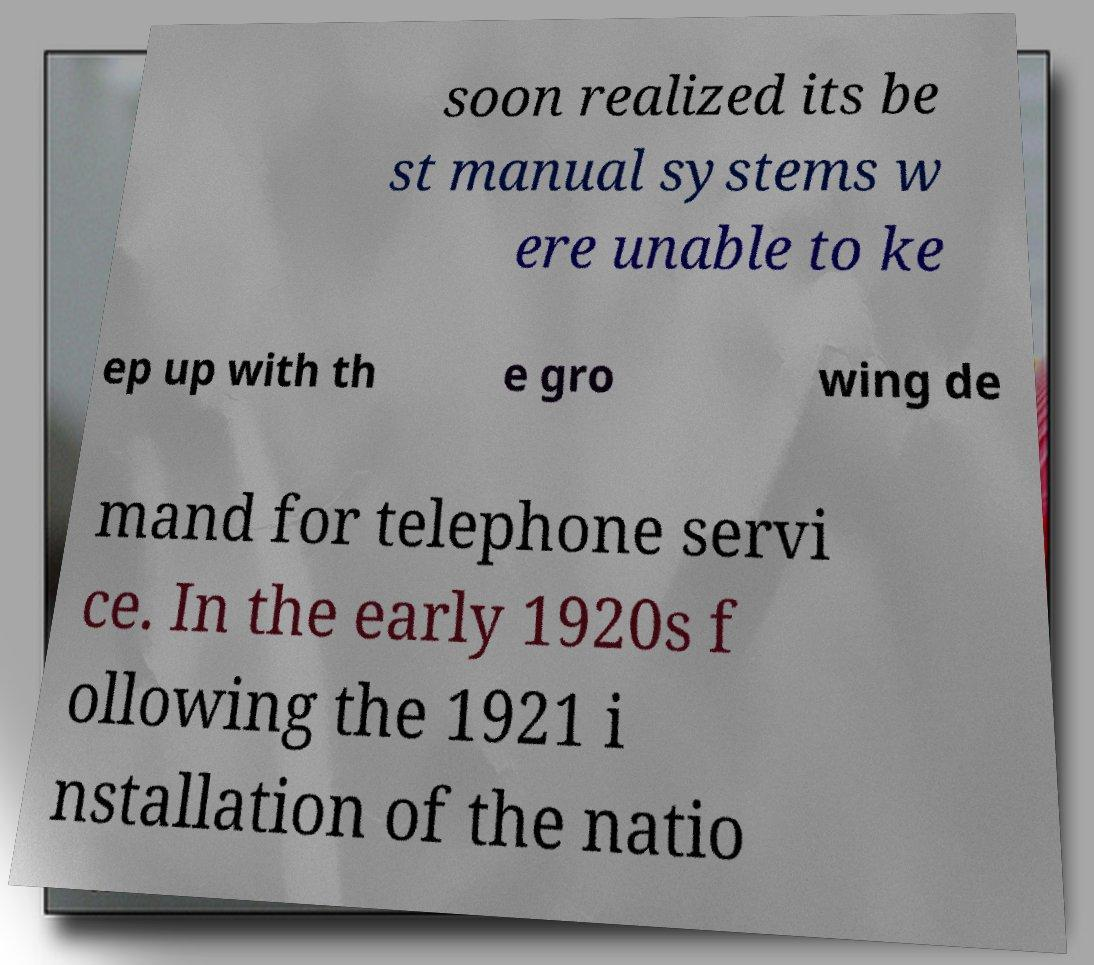I need the written content from this picture converted into text. Can you do that? soon realized its be st manual systems w ere unable to ke ep up with th e gro wing de mand for telephone servi ce. In the early 1920s f ollowing the 1921 i nstallation of the natio 